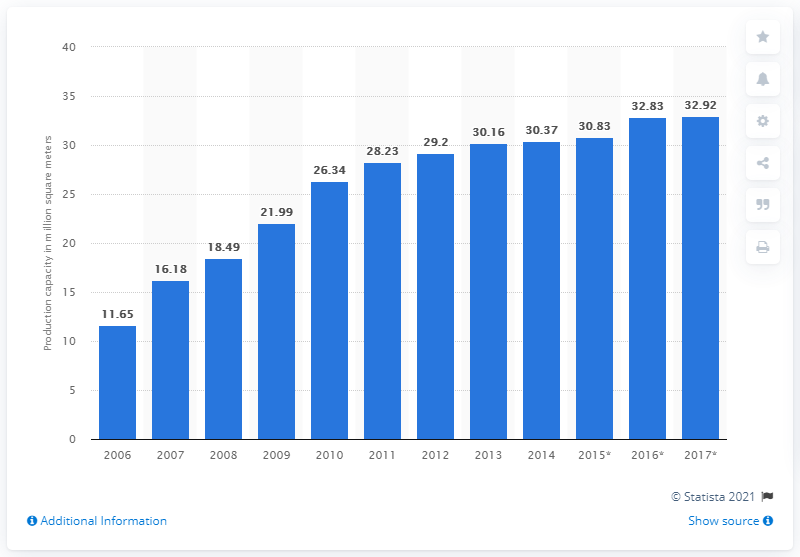Mention a couple of crucial points in this snapshot. In 2014, AUO's production capacity was 30.37 square meters. 